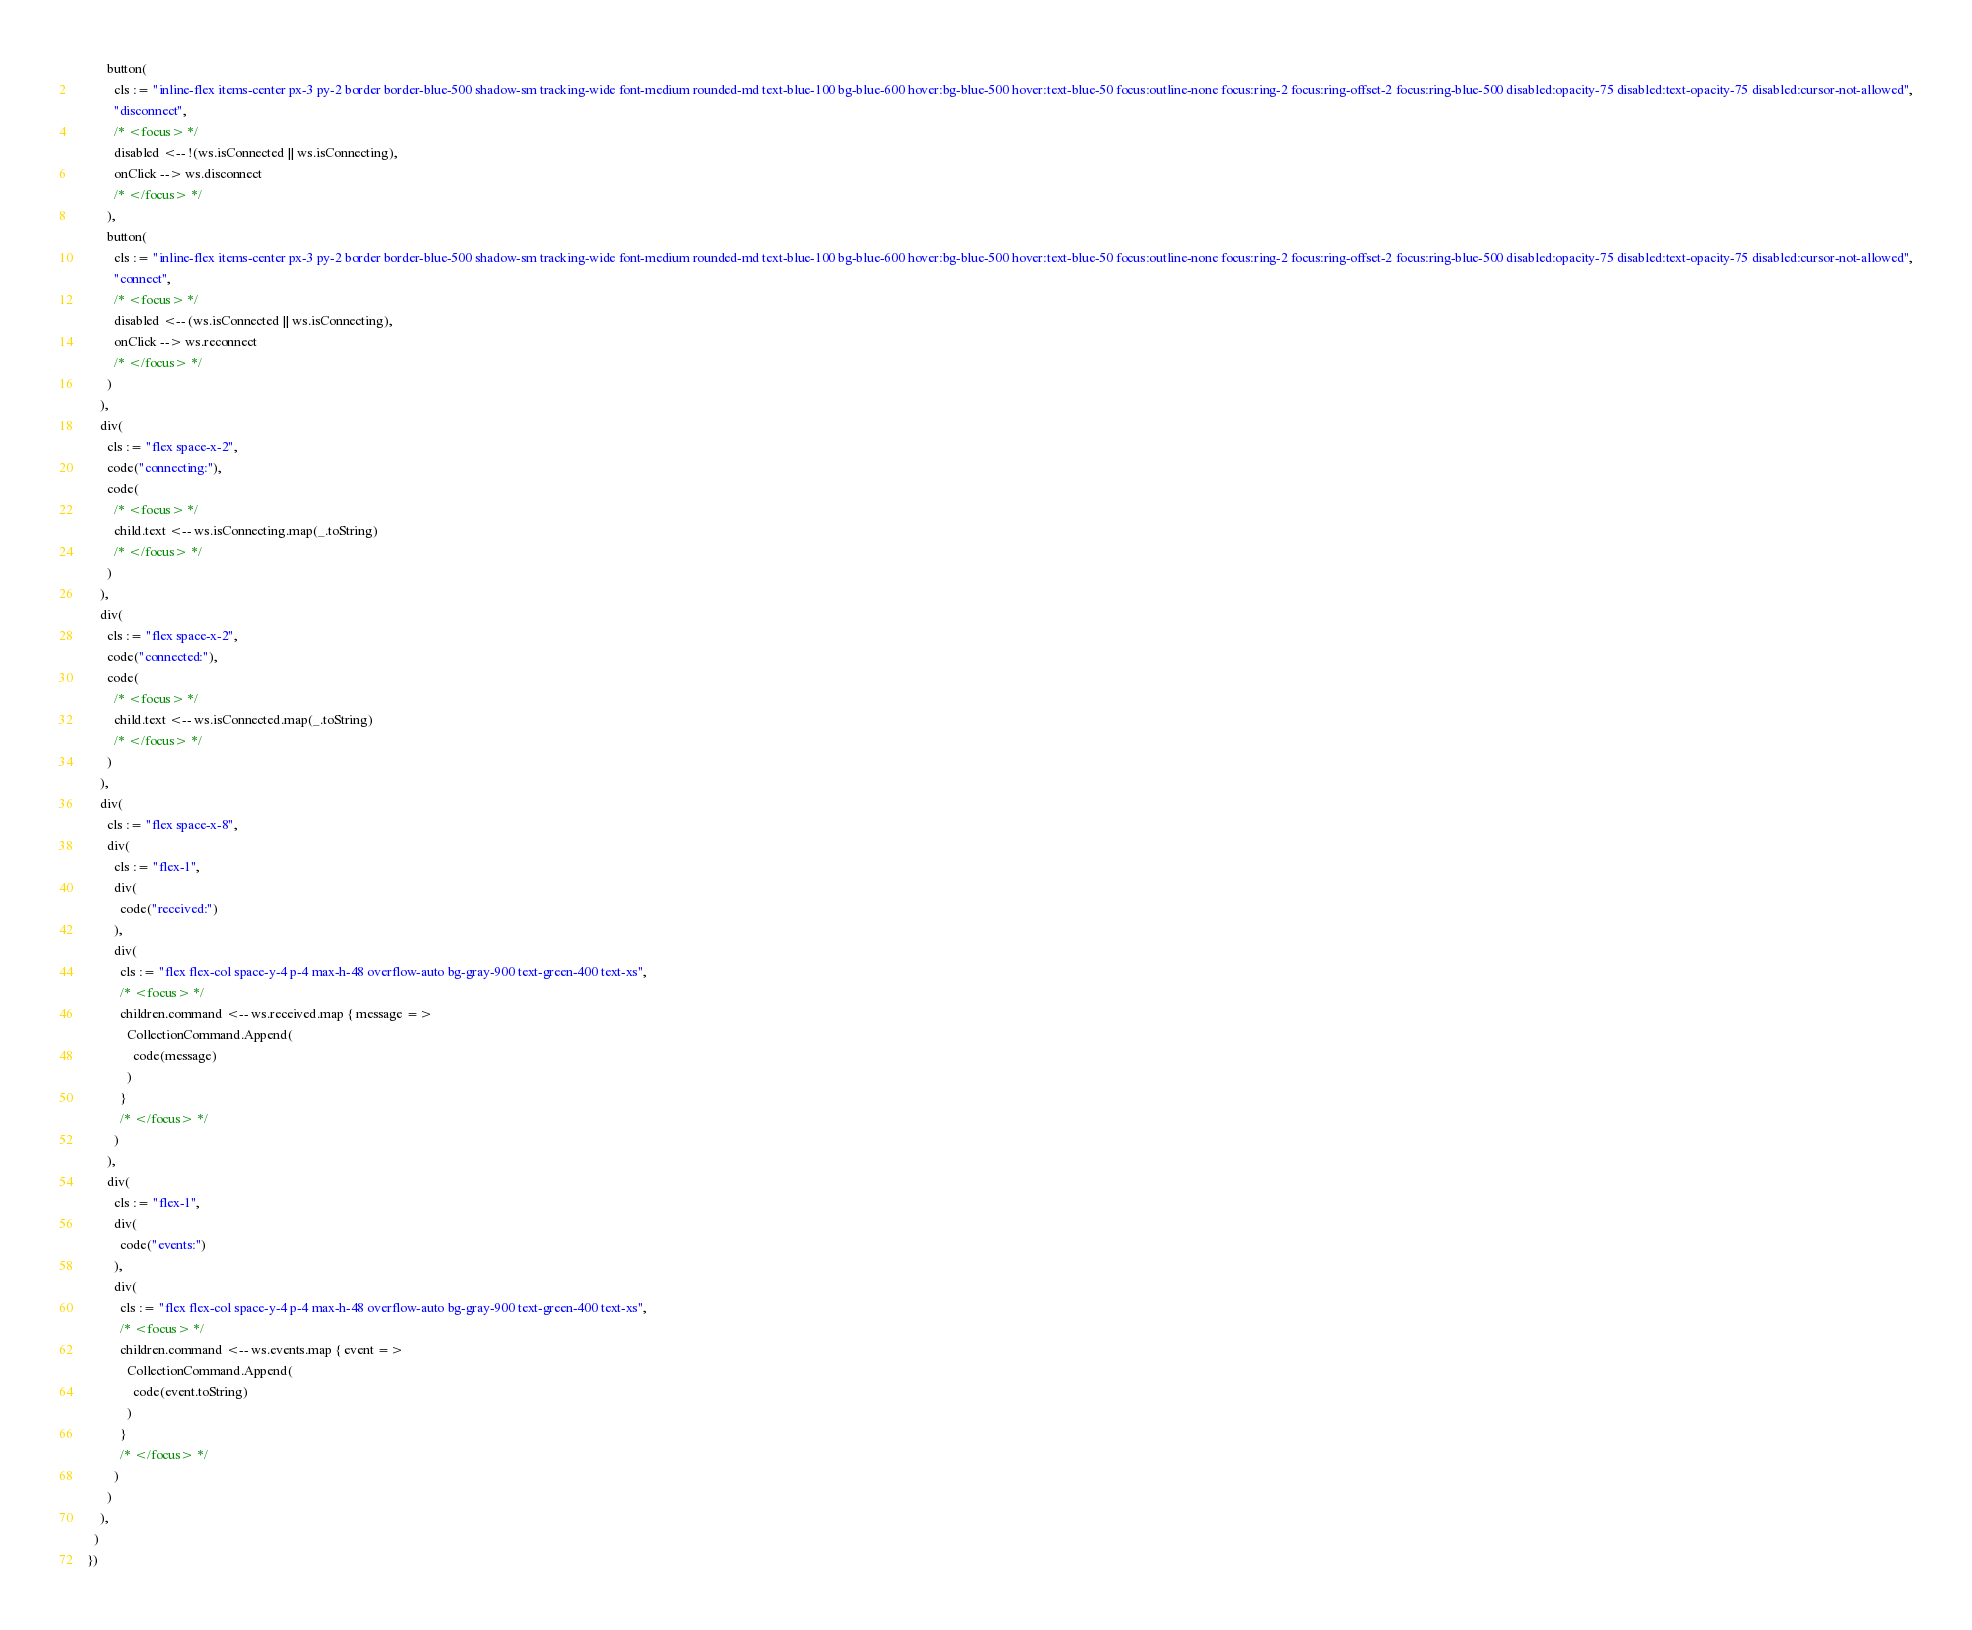Convert code to text. <code><loc_0><loc_0><loc_500><loc_500><_Scala_>          button(
            cls := "inline-flex items-center px-3 py-2 border border-blue-500 shadow-sm tracking-wide font-medium rounded-md text-blue-100 bg-blue-600 hover:bg-blue-500 hover:text-blue-50 focus:outline-none focus:ring-2 focus:ring-offset-2 focus:ring-blue-500 disabled:opacity-75 disabled:text-opacity-75 disabled:cursor-not-allowed",
            "disconnect",
            /* <focus> */
            disabled <-- !(ws.isConnected || ws.isConnecting),
            onClick --> ws.disconnect
            /* </focus> */
          ),
          button(
            cls := "inline-flex items-center px-3 py-2 border border-blue-500 shadow-sm tracking-wide font-medium rounded-md text-blue-100 bg-blue-600 hover:bg-blue-500 hover:text-blue-50 focus:outline-none focus:ring-2 focus:ring-offset-2 focus:ring-blue-500 disabled:opacity-75 disabled:text-opacity-75 disabled:cursor-not-allowed",
            "connect",
            /* <focus> */
            disabled <-- (ws.isConnected || ws.isConnecting),
            onClick --> ws.reconnect
            /* </focus> */
          )
        ),
        div(
          cls := "flex space-x-2",
          code("connecting:"),
          code(
            /* <focus> */
            child.text <-- ws.isConnecting.map(_.toString)
            /* </focus> */
          )
        ),
        div(
          cls := "flex space-x-2",
          code("connected:"),
          code(
            /* <focus> */
            child.text <-- ws.isConnected.map(_.toString)
            /* </focus> */
          )
        ),
        div(
          cls := "flex space-x-8",
          div(
            cls := "flex-1",
            div(
              code("received:")
            ),
            div(
              cls := "flex flex-col space-y-4 p-4 max-h-48 overflow-auto bg-gray-900 text-green-400 text-xs",
              /* <focus> */
              children.command <-- ws.received.map { message =>
                CollectionCommand.Append(
                  code(message)
                )
              }
              /* </focus> */
            )
          ),
          div(
            cls := "flex-1",
            div(
              code("events:")
            ),
            div(
              cls := "flex flex-col space-y-4 p-4 max-h-48 overflow-auto bg-gray-900 text-green-400 text-xs",
              /* <focus> */
              children.command <-- ws.events.map { event =>
                CollectionCommand.Append(
                  code(event.toString)
                )
              }
              /* </focus> */
            )
          )
        ),
      )
    })
</code> 